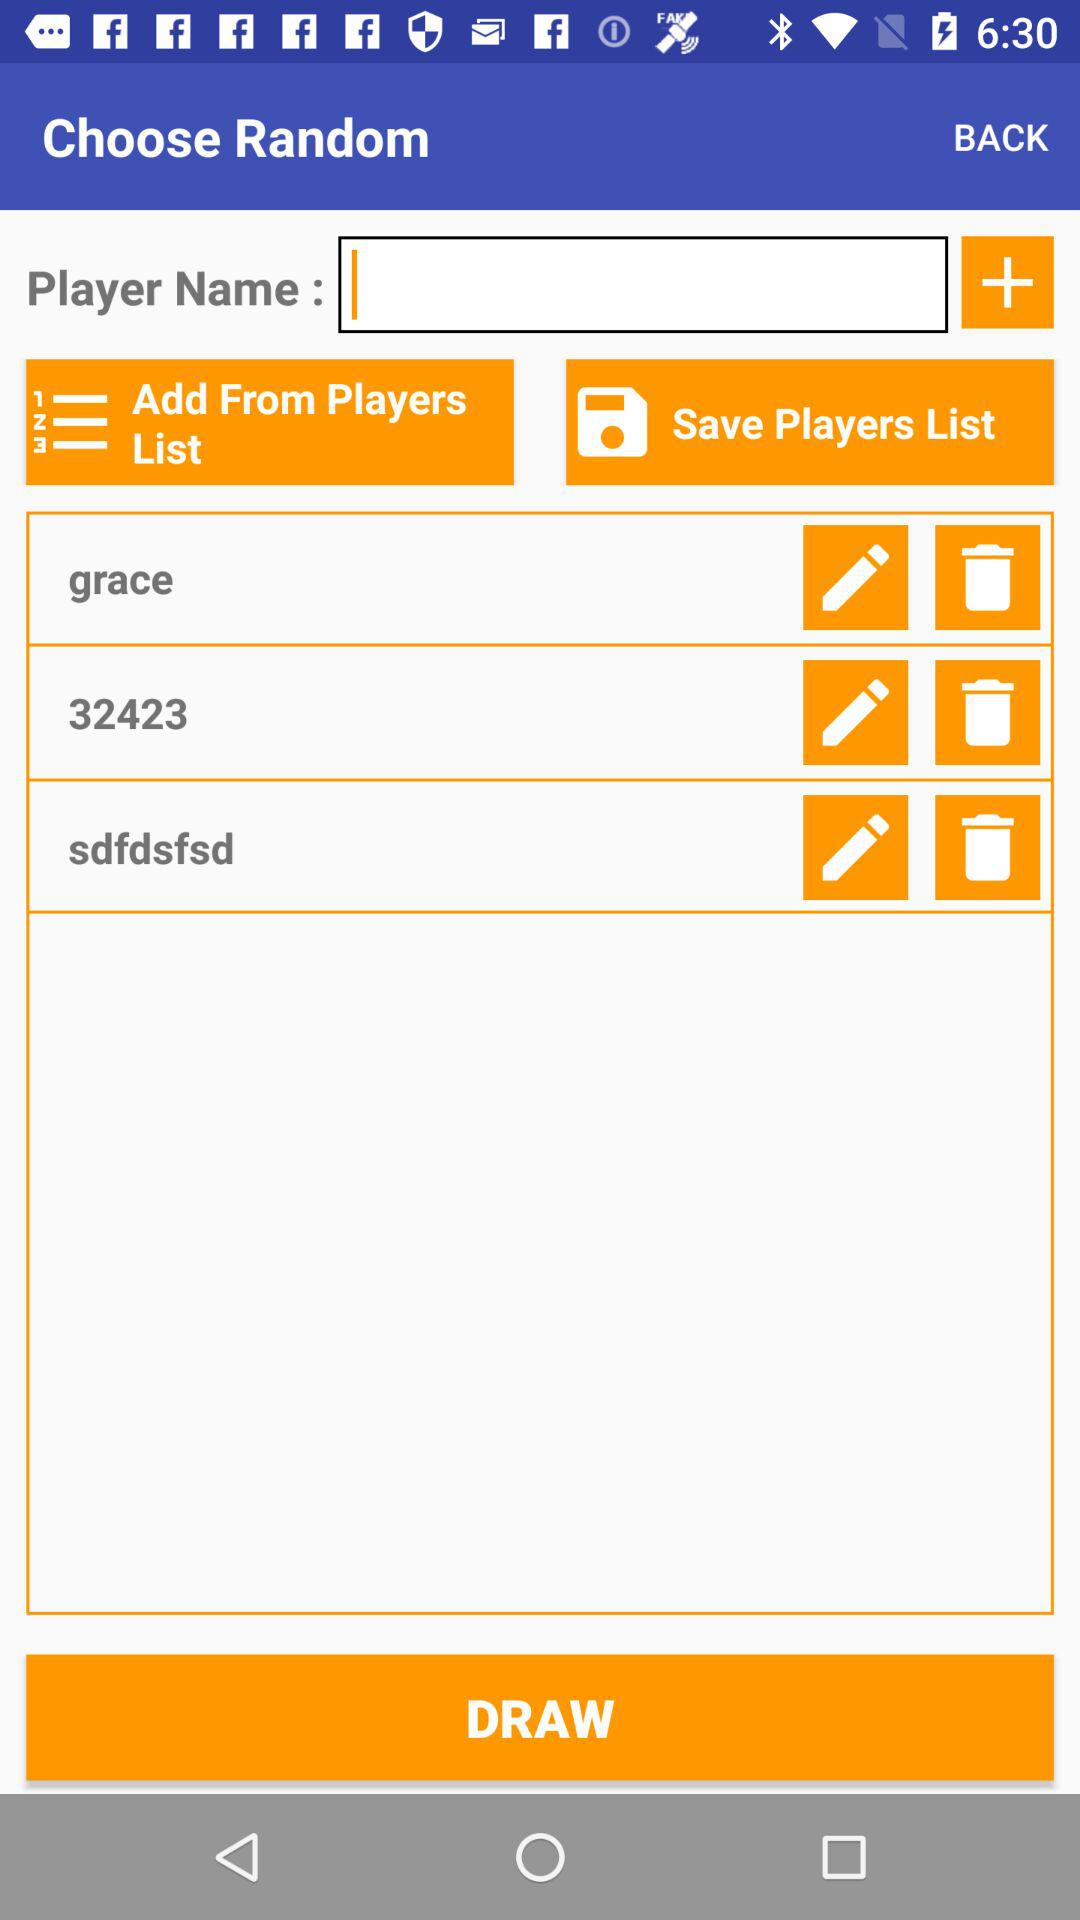What are the names of the players? The names of the players are "grace", "32423" and "sdfdsfsd". 